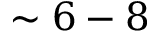Convert formula to latex. <formula><loc_0><loc_0><loc_500><loc_500>\sim 6 - 8</formula> 